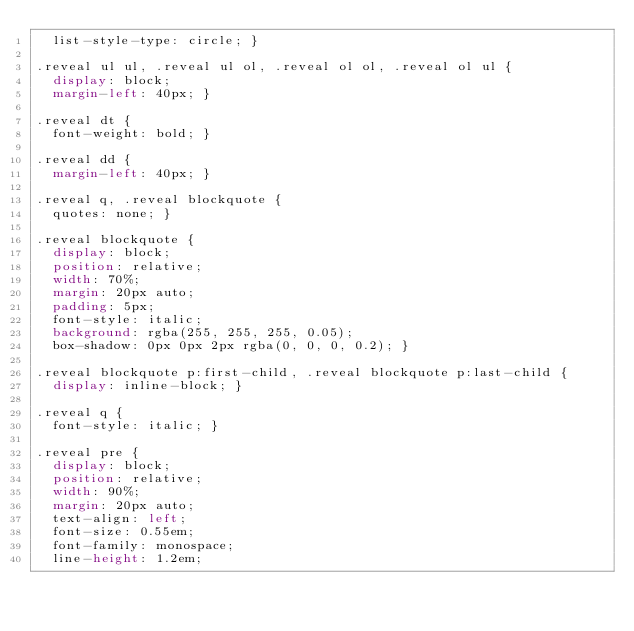Convert code to text. <code><loc_0><loc_0><loc_500><loc_500><_CSS_>  list-style-type: circle; }

.reveal ul ul, .reveal ul ol, .reveal ol ol, .reveal ol ul {
  display: block;
  margin-left: 40px; }

.reveal dt {
  font-weight: bold; }

.reveal dd {
  margin-left: 40px; }

.reveal q, .reveal blockquote {
  quotes: none; }

.reveal blockquote {
  display: block;
  position: relative;
  width: 70%;
  margin: 20px auto;
  padding: 5px;
  font-style: italic;
  background: rgba(255, 255, 255, 0.05);
  box-shadow: 0px 0px 2px rgba(0, 0, 0, 0.2); }

.reveal blockquote p:first-child, .reveal blockquote p:last-child {
  display: inline-block; }

.reveal q {
  font-style: italic; }

.reveal pre {
  display: block;
  position: relative;
  width: 90%;
  margin: 20px auto;
  text-align: left;
  font-size: 0.55em;
  font-family: monospace;
  line-height: 1.2em;</code> 